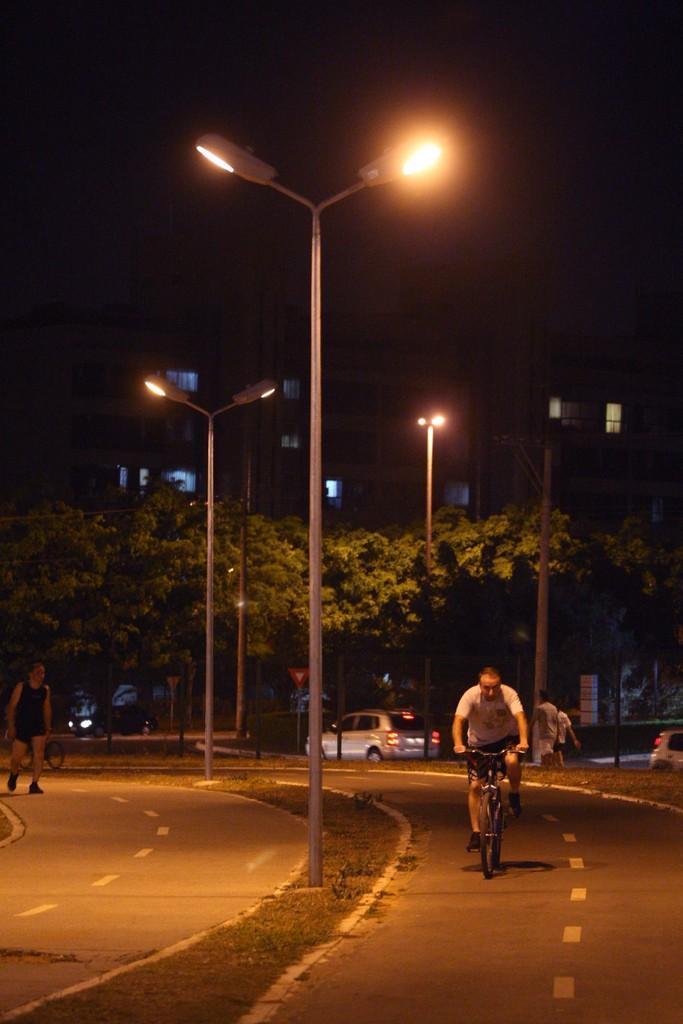Describe this image in one or two sentences. In this picture we can see a person sitting on a bicycle. There are a few people on the road. We can see some grass on the ground. There are vehicles, street lights, buildings and other objects. We can see the dark view in the background. 